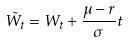<formula> <loc_0><loc_0><loc_500><loc_500>\tilde { W } _ { t } = W _ { t } + \frac { \mu - r } { \sigma } t</formula> 